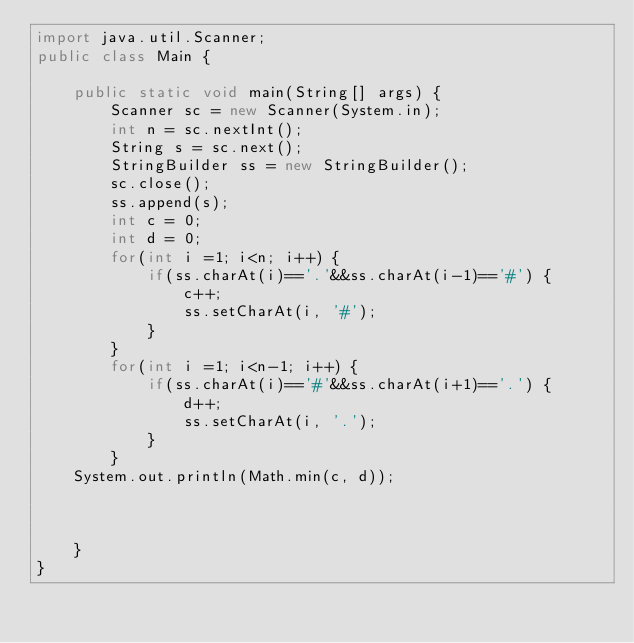Convert code to text. <code><loc_0><loc_0><loc_500><loc_500><_Java_>import java.util.Scanner;
public class Main {
 
	public static void main(String[] args) {
		Scanner sc = new Scanner(System.in);
		int n = sc.nextInt();
		String s = sc.next();
		StringBuilder ss = new StringBuilder();
		sc.close();
		ss.append(s);
		int c = 0;
		int d = 0;
		for(int i =1; i<n; i++) {
			if(ss.charAt(i)=='.'&&ss.charAt(i-1)=='#') {
				c++;
				ss.setCharAt(i, '#');
			}
		}
		for(int i =1; i<n-1; i++) {
			if(ss.charAt(i)=='#'&&ss.charAt(i+1)=='.') {
				d++;
				ss.setCharAt(i, '.');
			}
		}
	System.out.println(Math.min(c, d));
	
	
	
	}
}</code> 